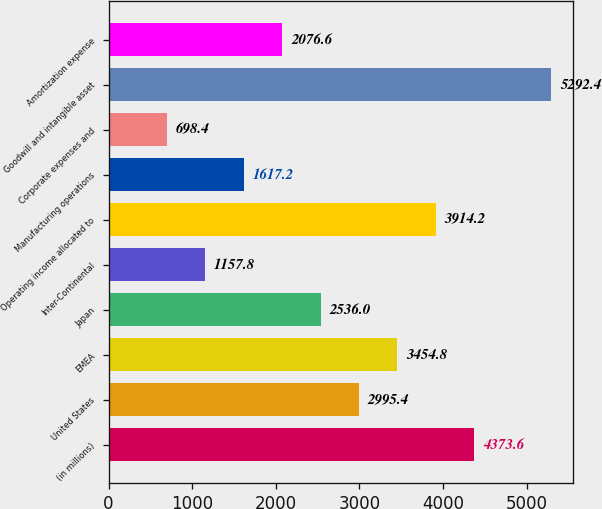<chart> <loc_0><loc_0><loc_500><loc_500><bar_chart><fcel>(in millions)<fcel>United States<fcel>EMEA<fcel>Japan<fcel>Inter-Continental<fcel>Operating income allocated to<fcel>Manufacturing operations<fcel>Corporate expenses and<fcel>Goodwill and intangible asset<fcel>Amortization expense<nl><fcel>4373.6<fcel>2995.4<fcel>3454.8<fcel>2536<fcel>1157.8<fcel>3914.2<fcel>1617.2<fcel>698.4<fcel>5292.4<fcel>2076.6<nl></chart> 